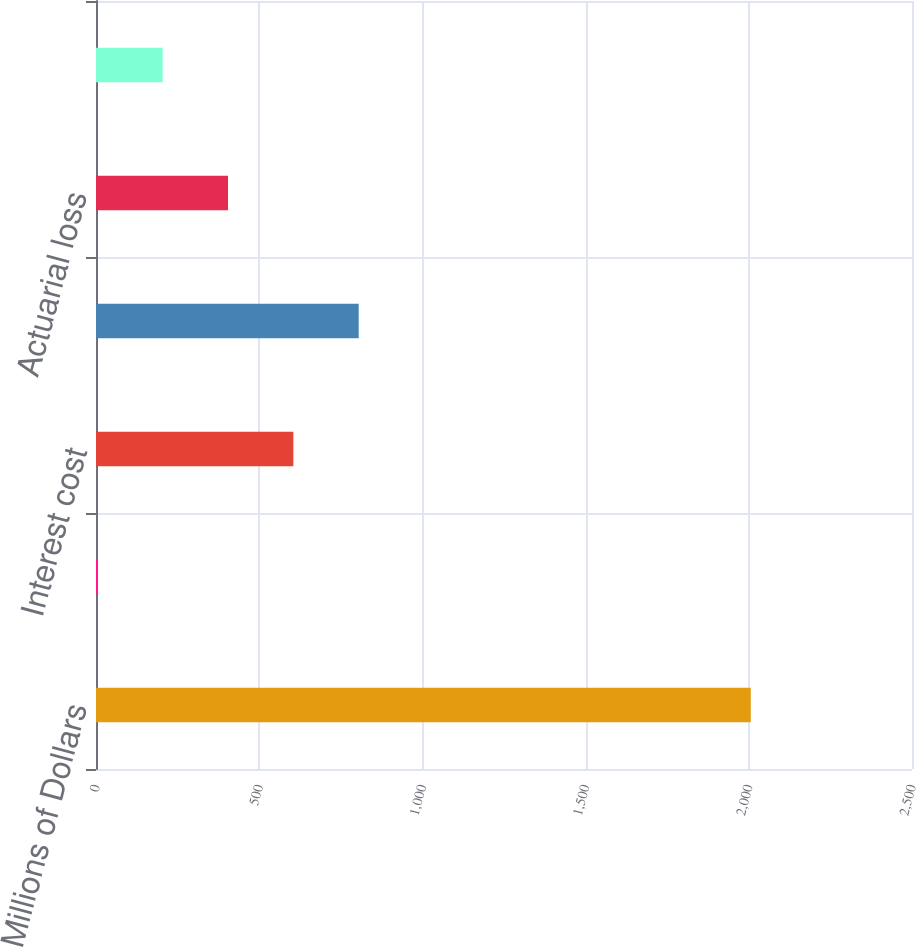Convert chart to OTSL. <chart><loc_0><loc_0><loc_500><loc_500><bar_chart><fcel>Millions of Dollars<fcel>Service cost<fcel>Interest cost<fcel>Prior service cost/(credit)<fcel>Actuarial loss<fcel>Net periodic benefit<nl><fcel>2006<fcel>4<fcel>604.6<fcel>804.8<fcel>404.4<fcel>204.2<nl></chart> 